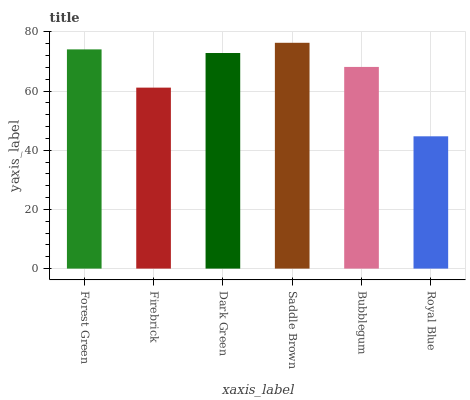Is Royal Blue the minimum?
Answer yes or no. Yes. Is Saddle Brown the maximum?
Answer yes or no. Yes. Is Firebrick the minimum?
Answer yes or no. No. Is Firebrick the maximum?
Answer yes or no. No. Is Forest Green greater than Firebrick?
Answer yes or no. Yes. Is Firebrick less than Forest Green?
Answer yes or no. Yes. Is Firebrick greater than Forest Green?
Answer yes or no. No. Is Forest Green less than Firebrick?
Answer yes or no. No. Is Dark Green the high median?
Answer yes or no. Yes. Is Bubblegum the low median?
Answer yes or no. Yes. Is Saddle Brown the high median?
Answer yes or no. No. Is Saddle Brown the low median?
Answer yes or no. No. 